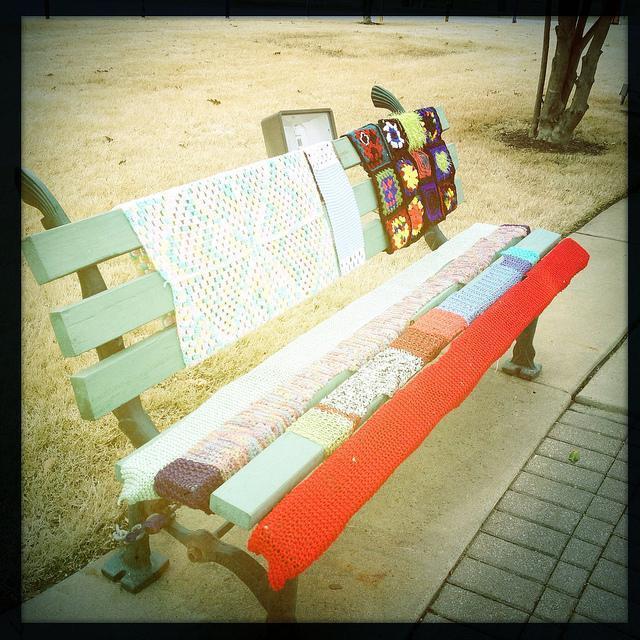How many people can sit on this bench?
Give a very brief answer. 3. 